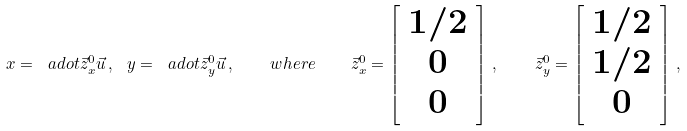Convert formula to latex. <formula><loc_0><loc_0><loc_500><loc_500>x = \ a d o t { \vec { z } _ { x } ^ { 0 } } { \vec { u } } \, , \ y = \ a d o t { \vec { z } _ { y } ^ { 0 } } { \vec { u } } \, , \quad w h e r e \quad \vec { z } _ { x } ^ { 0 } = \left [ \begin{array} { c } 1 / 2 \\ 0 \\ 0 \end{array} \right ] \, , \quad \vec { z } _ { y } ^ { 0 } = \left [ \begin{array} { c } 1 / 2 \\ 1 / 2 \\ 0 \end{array} \right ] \, ,</formula> 